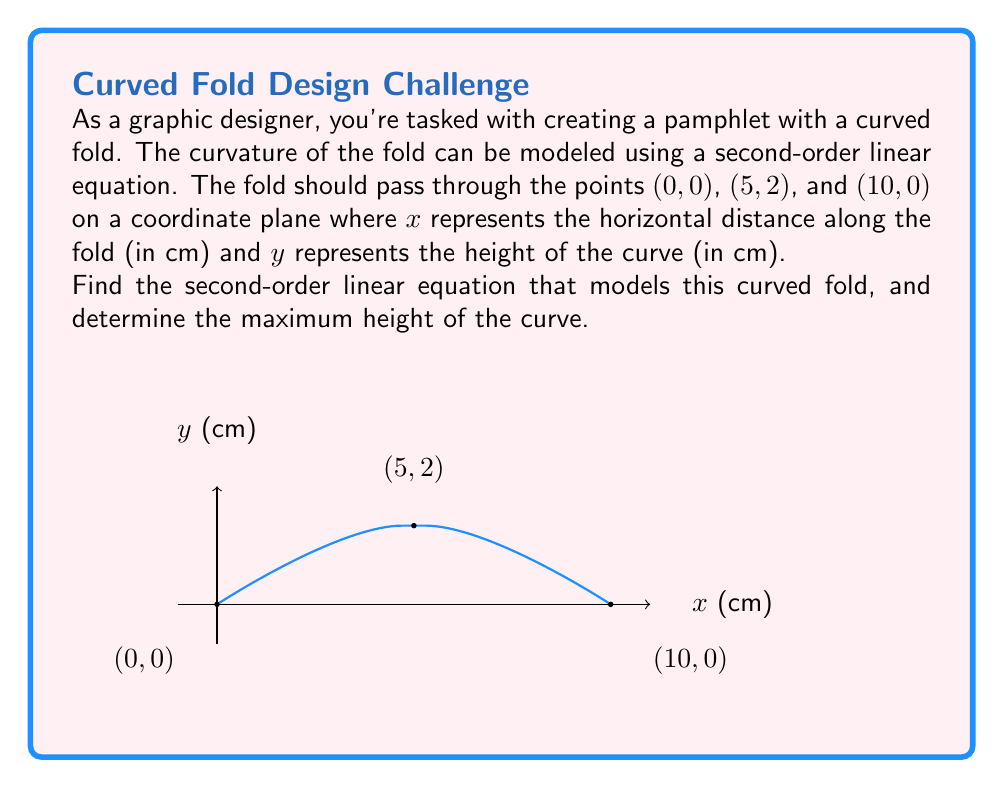What is the answer to this math problem? Let's approach this step-by-step:

1) The general form of a second-order linear equation is:
   $$y = ax^2 + bx + c$$

2) We know three points that the curve passes through:
   (0, 0), (5, 2), and (10, 0)

3) Let's substitute these points into the general equation:
   For (0, 0): $0 = a(0)^2 + b(0) + c$, so $c = 0$
   For (5, 2): $2 = a(5)^2 + b(5) + 0$
   For (10, 0): $0 = a(10)^2 + b(10) + 0$

4) Now we have two equations:
   $2 = 25a + 5b$ ... (1)
   $0 = 100a + 10b$ ... (2)

5) Multiply equation (1) by 4:
   $8 = 100a + 20b$ ... (3)

6) Subtract equation (2) from (3):
   $8 = 10b$
   $b = 0.8$

7) Substitute this value of b into equation (1):
   $2 = 25a + 5(0.8)$
   $2 = 25a + 4$
   $-2 = 25a$
   $a = -0.08$

8) Therefore, the equation is:
   $$y = -0.08x^2 + 0.8x$$

9) To find the maximum height, we need to find the vertex of the parabola.
   The x-coordinate of the vertex is given by $x = -b/(2a)$:
   $$x = -0.8 / (2(-0.08)) = 5$$

10) Substitute x = 5 into the equation to find the maximum height:
    $$y = -0.08(5)^2 + 0.8(5) = -2 + 4 = 2$$

Therefore, the maximum height of the curve is 2 cm.
Answer: $y = -0.08x^2 + 0.8x$; Maximum height: 2 cm 